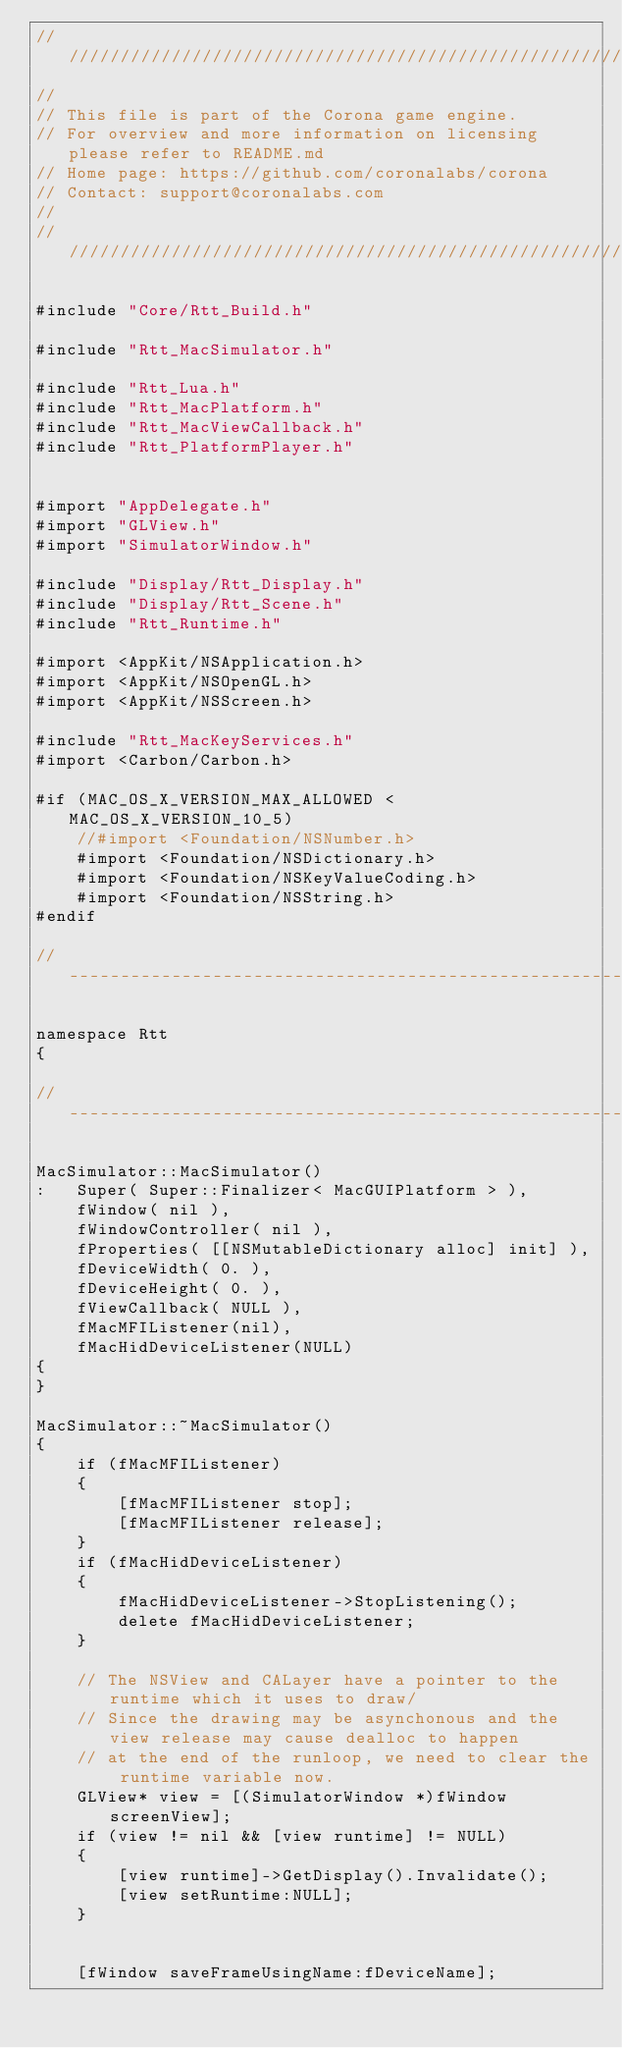Convert code to text. <code><loc_0><loc_0><loc_500><loc_500><_ObjectiveC_>//////////////////////////////////////////////////////////////////////////////
//
// This file is part of the Corona game engine.
// For overview and more information on licensing please refer to README.md 
// Home page: https://github.com/coronalabs/corona
// Contact: support@coronalabs.com
//
//////////////////////////////////////////////////////////////////////////////

#include "Core/Rtt_Build.h"

#include "Rtt_MacSimulator.h"

#include "Rtt_Lua.h"
#include "Rtt_MacPlatform.h"
#include "Rtt_MacViewCallback.h"
#include "Rtt_PlatformPlayer.h"


#import "AppDelegate.h"
#import "GLView.h"
#import "SimulatorWindow.h"

#include "Display/Rtt_Display.h"
#include "Display/Rtt_Scene.h"
#include "Rtt_Runtime.h"

#import <AppKit/NSApplication.h>
#import <AppKit/NSOpenGL.h>
#import <AppKit/NSScreen.h>

#include "Rtt_MacKeyServices.h"
#import <Carbon/Carbon.h>

#if (MAC_OS_X_VERSION_MAX_ALLOWED < MAC_OS_X_VERSION_10_5)
	//#import <Foundation/NSNumber.h>
	#import <Foundation/NSDictionary.h>
	#import <Foundation/NSKeyValueCoding.h>
	#import <Foundation/NSString.h>
#endif

// ----------------------------------------------------------------------------

namespace Rtt
{

// ----------------------------------------------------------------------------

MacSimulator::MacSimulator()
:	Super( Super::Finalizer< MacGUIPlatform > ),
	fWindow( nil ),
	fWindowController( nil ),
	fProperties( [[NSMutableDictionary alloc] init] ),
	fDeviceWidth( 0. ),
	fDeviceHeight( 0. ),
	fViewCallback( NULL ),
	fMacMFIListener(nil),
	fMacHidDeviceListener(NULL)
{
}

MacSimulator::~MacSimulator()
{
	if (fMacMFIListener)
	{
		[fMacMFIListener stop];
		[fMacMFIListener release];
	}
	if (fMacHidDeviceListener)
	{
		fMacHidDeviceListener->StopListening();
		delete fMacHidDeviceListener;
	}

	// The NSView and CALayer have a pointer to the runtime which it uses to draw/
	// Since the drawing may be asynchonous and the view release may cause dealloc to happen
	// at the end of the runloop, we need to clear the runtime variable now.
	GLView* view = [(SimulatorWindow *)fWindow screenView];
    if (view != nil && [view runtime] != NULL)
    {
        [view runtime]->GetDisplay().Invalidate();
        [view setRuntime:NULL];
    }


    [fWindow saveFrameUsingName:fDeviceName];</code> 